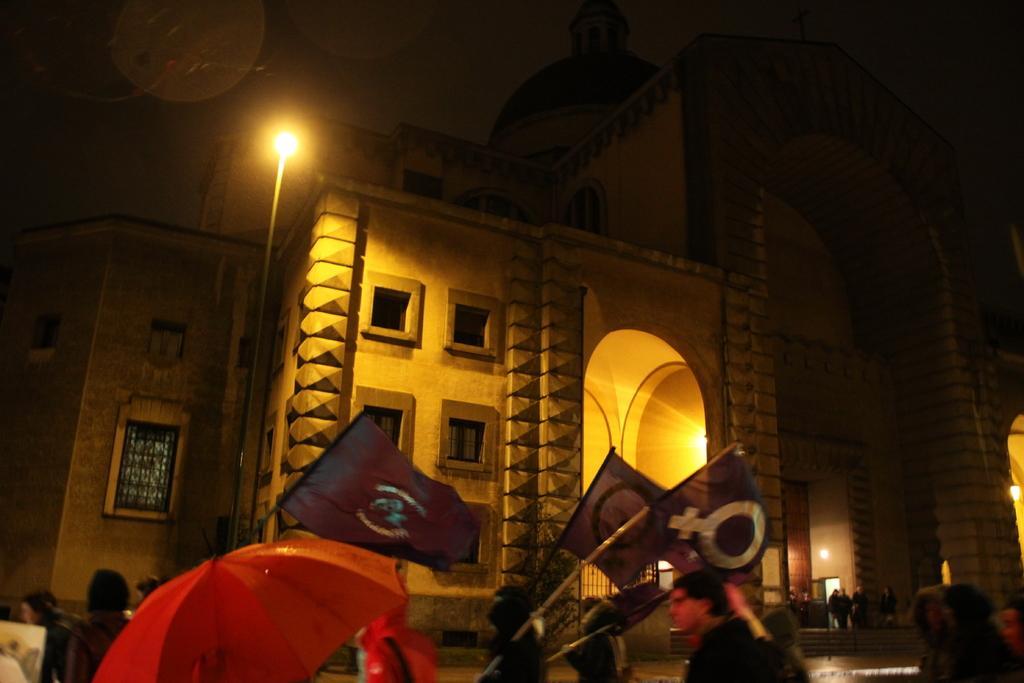Describe this image in one or two sentences. In the picture we can see group of people walking along the road holding some flags in their hands and in the background of the picture there is building and we can see some lights. 